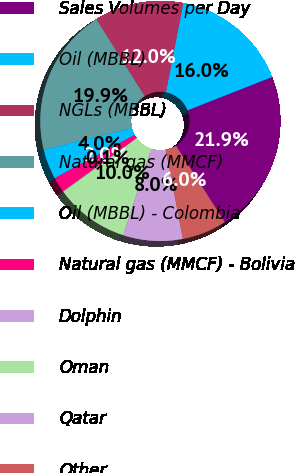<chart> <loc_0><loc_0><loc_500><loc_500><pie_chart><fcel>Sales Volumes per Day<fcel>Oil (MBBL)<fcel>NGLs (MBBL)<fcel>Natural gas (MMCF)<fcel>Oil (MBBL) - Colombia<fcel>Natural gas (MMCF) - Bolivia<fcel>Dolphin<fcel>Oman<fcel>Qatar<fcel>Other<nl><fcel>21.93%<fcel>15.96%<fcel>11.99%<fcel>19.94%<fcel>4.04%<fcel>2.05%<fcel>0.06%<fcel>10.0%<fcel>8.01%<fcel>6.02%<nl></chart> 